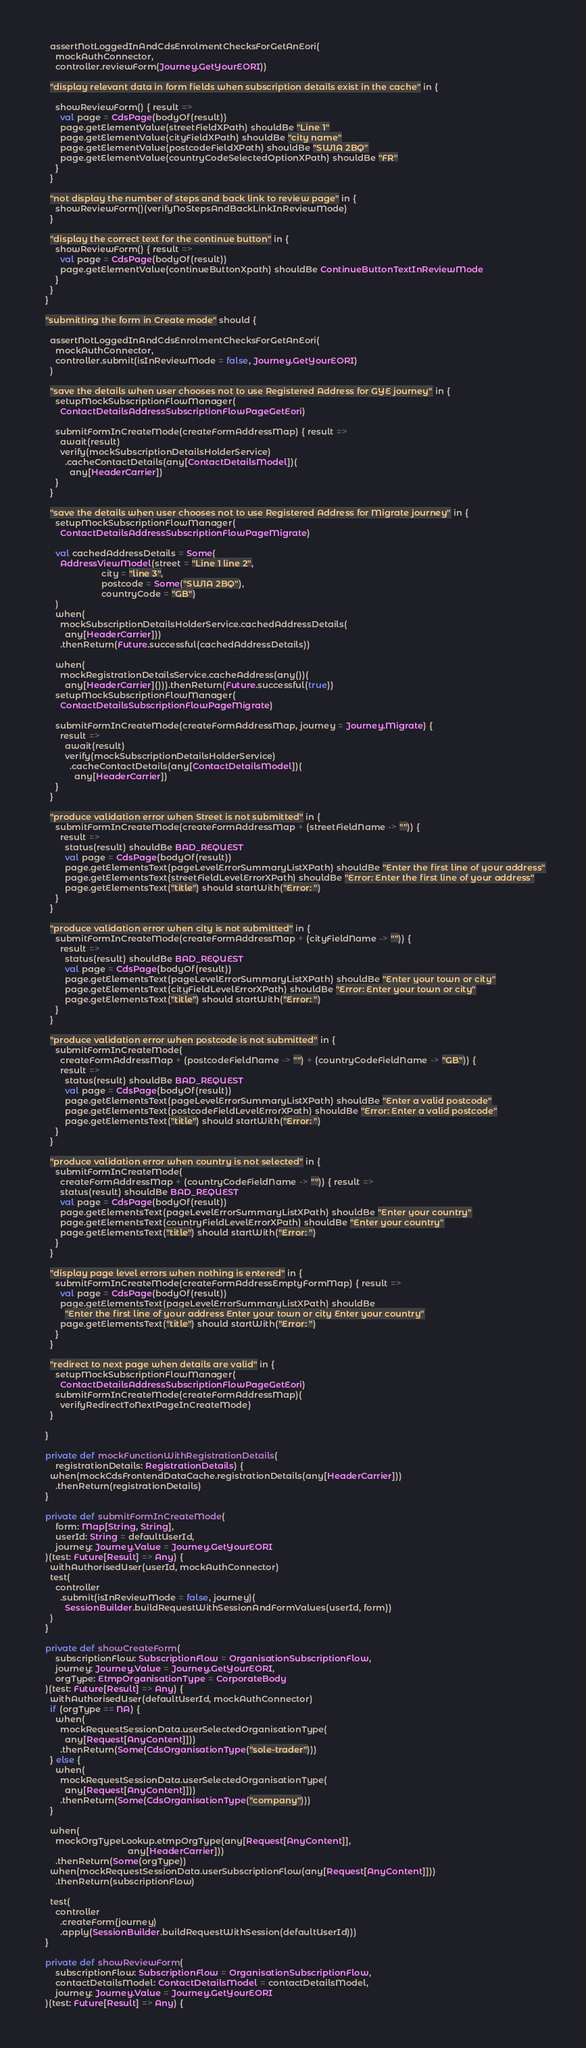<code> <loc_0><loc_0><loc_500><loc_500><_Scala_>    assertNotLoggedInAndCdsEnrolmentChecksForGetAnEori(
      mockAuthConnector,
      controller.reviewForm(Journey.GetYourEORI))

    "display relevant data in form fields when subscription details exist in the cache" in {

      showReviewForm() { result =>
        val page = CdsPage(bodyOf(result))
        page.getElementValue(streetFieldXPath) shouldBe "Line 1"
        page.getElementValue(cityFieldXPath) shouldBe "city name"
        page.getElementValue(postcodeFieldXPath) shouldBe "SW1A 2BQ"
        page.getElementValue(countryCodeSelectedOptionXPath) shouldBe "FR"
      }
    }

    "not display the number of steps and back link to review page" in {
      showReviewForm()(verifyNoStepsAndBackLinkInReviewMode)
    }

    "display the correct text for the continue button" in {
      showReviewForm() { result =>
        val page = CdsPage(bodyOf(result))
        page.getElementValue(continueButtonXpath) shouldBe ContinueButtonTextInReviewMode
      }
    }
  }

  "submitting the form in Create mode" should {

    assertNotLoggedInAndCdsEnrolmentChecksForGetAnEori(
      mockAuthConnector,
      controller.submit(isInReviewMode = false, Journey.GetYourEORI)
    )

    "save the details when user chooses not to use Registered Address for GYE journey" in {
      setupMockSubscriptionFlowManager(
        ContactDetailsAddressSubscriptionFlowPageGetEori)

      submitFormInCreateMode(createFormAddressMap) { result =>
        await(result)
        verify(mockSubscriptionDetailsHolderService)
          .cacheContactDetails(any[ContactDetailsModel])(
            any[HeaderCarrier])
      }
    }

    "save the details when user chooses not to use Registered Address for Migrate journey" in {
      setupMockSubscriptionFlowManager(
        ContactDetailsAddressSubscriptionFlowPageMigrate)

      val cachedAddressDetails = Some(
        AddressViewModel(street = "Line 1 line 2",
                         city = "line 3",
                         postcode = Some("SW1A 2BQ"),
                         countryCode = "GB")
      )
      when(
        mockSubscriptionDetailsHolderService.cachedAddressDetails(
          any[HeaderCarrier]))
        .thenReturn(Future.successful(cachedAddressDetails))

      when(
        mockRegistrationDetailsService.cacheAddress(any())(
          any[HeaderCarrier]())).thenReturn(Future.successful(true))
      setupMockSubscriptionFlowManager(
        ContactDetailsSubscriptionFlowPageMigrate)

      submitFormInCreateMode(createFormAddressMap, journey = Journey.Migrate) {
        result =>
          await(result)
          verify(mockSubscriptionDetailsHolderService)
            .cacheContactDetails(any[ContactDetailsModel])(
              any[HeaderCarrier])
      }
    }

    "produce validation error when Street is not submitted" in {
      submitFormInCreateMode(createFormAddressMap + (streetFieldName -> "")) {
        result =>
          status(result) shouldBe BAD_REQUEST
          val page = CdsPage(bodyOf(result))
          page.getElementsText(pageLevelErrorSummaryListXPath) shouldBe "Enter the first line of your address"
          page.getElementsText(streetFieldLevelErrorXPath) shouldBe "Error: Enter the first line of your address"
          page.getElementsText("title") should startWith("Error: ")
      }
    }

    "produce validation error when city is not submitted" in {
      submitFormInCreateMode(createFormAddressMap + (cityFieldName -> "")) {
        result =>
          status(result) shouldBe BAD_REQUEST
          val page = CdsPage(bodyOf(result))
          page.getElementsText(pageLevelErrorSummaryListXPath) shouldBe "Enter your town or city"
          page.getElementsText(cityFieldLevelErrorXPath) shouldBe "Error: Enter your town or city"
          page.getElementsText("title") should startWith("Error: ")
      }
    }

    "produce validation error when postcode is not submitted" in {
      submitFormInCreateMode(
        createFormAddressMap + (postcodeFieldName -> "") + (countryCodeFieldName -> "GB")) {
        result =>
          status(result) shouldBe BAD_REQUEST
          val page = CdsPage(bodyOf(result))
          page.getElementsText(pageLevelErrorSummaryListXPath) shouldBe "Enter a valid postcode"
          page.getElementsText(postcodeFieldLevelErrorXPath) shouldBe "Error: Enter a valid postcode"
          page.getElementsText("title") should startWith("Error: ")
      }
    }

    "produce validation error when country is not selected" in {
      submitFormInCreateMode(
        createFormAddressMap + (countryCodeFieldName -> "")) { result =>
        status(result) shouldBe BAD_REQUEST
        val page = CdsPage(bodyOf(result))
        page.getElementsText(pageLevelErrorSummaryListXPath) shouldBe "Enter your country"
        page.getElementsText(countryFieldLevelErrorXPath) shouldBe "Enter your country"
        page.getElementsText("title") should startWith("Error: ")
      }
    }

    "display page level errors when nothing is entered" in {
      submitFormInCreateMode(createFormAddressEmptyFormMap) { result =>
        val page = CdsPage(bodyOf(result))
        page.getElementsText(pageLevelErrorSummaryListXPath) shouldBe
          "Enter the first line of your address Enter your town or city Enter your country"
        page.getElementsText("title") should startWith("Error: ")
      }
    }

    "redirect to next page when details are valid" in {
      setupMockSubscriptionFlowManager(
        ContactDetailsAddressSubscriptionFlowPageGetEori)
      submitFormInCreateMode(createFormAddressMap)(
        verifyRedirectToNextPageInCreateMode)
    }

  }

  private def mockFunctionWithRegistrationDetails(
      registrationDetails: RegistrationDetails) {
    when(mockCdsFrontendDataCache.registrationDetails(any[HeaderCarrier]))
      .thenReturn(registrationDetails)
  }

  private def submitFormInCreateMode(
      form: Map[String, String],
      userId: String = defaultUserId,
      journey: Journey.Value = Journey.GetYourEORI
  )(test: Future[Result] => Any) {
    withAuthorisedUser(userId, mockAuthConnector)
    test(
      controller
        .submit(isInReviewMode = false, journey)(
          SessionBuilder.buildRequestWithSessionAndFormValues(userId, form))
    )
  }

  private def showCreateForm(
      subscriptionFlow: SubscriptionFlow = OrganisationSubscriptionFlow,
      journey: Journey.Value = Journey.GetYourEORI,
      orgType: EtmpOrganisationType = CorporateBody
  )(test: Future[Result] => Any) {
    withAuthorisedUser(defaultUserId, mockAuthConnector)
    if (orgType == NA) {
      when(
        mockRequestSessionData.userSelectedOrganisationType(
          any[Request[AnyContent]]))
        .thenReturn(Some(CdsOrganisationType("sole-trader")))
    } else {
      when(
        mockRequestSessionData.userSelectedOrganisationType(
          any[Request[AnyContent]]))
        .thenReturn(Some(CdsOrganisationType("company")))
    }

    when(
      mockOrgTypeLookup.etmpOrgType(any[Request[AnyContent]],
                                    any[HeaderCarrier]))
      .thenReturn(Some(orgType))
    when(mockRequestSessionData.userSubscriptionFlow(any[Request[AnyContent]]))
      .thenReturn(subscriptionFlow)

    test(
      controller
        .createForm(journey)
        .apply(SessionBuilder.buildRequestWithSession(defaultUserId)))
  }

  private def showReviewForm(
      subscriptionFlow: SubscriptionFlow = OrganisationSubscriptionFlow,
      contactDetailsModel: ContactDetailsModel = contactDetailsModel,
      journey: Journey.Value = Journey.GetYourEORI
  )(test: Future[Result] => Any) {</code> 